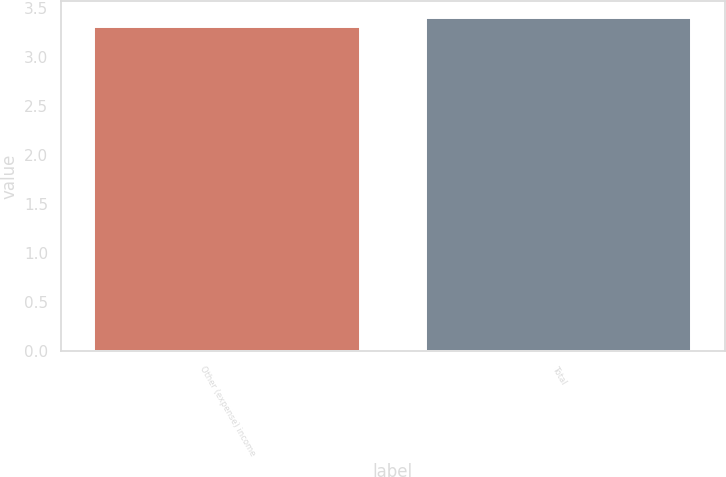<chart> <loc_0><loc_0><loc_500><loc_500><bar_chart><fcel>Other (expense) income<fcel>Total<nl><fcel>3.3<fcel>3.4<nl></chart> 